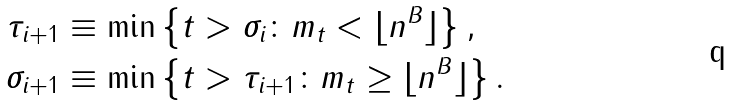Convert formula to latex. <formula><loc_0><loc_0><loc_500><loc_500>\tau _ { i + 1 } & \equiv \min \left \{ t > \sigma _ { i } \colon m _ { t } < \lfloor n ^ { B } \rfloor \right \} , \\ \sigma _ { i + 1 } & \equiv \min \left \{ t > \tau _ { i + 1 } \colon m _ { t } \geq \lfloor n ^ { B } \rfloor \right \} .</formula> 